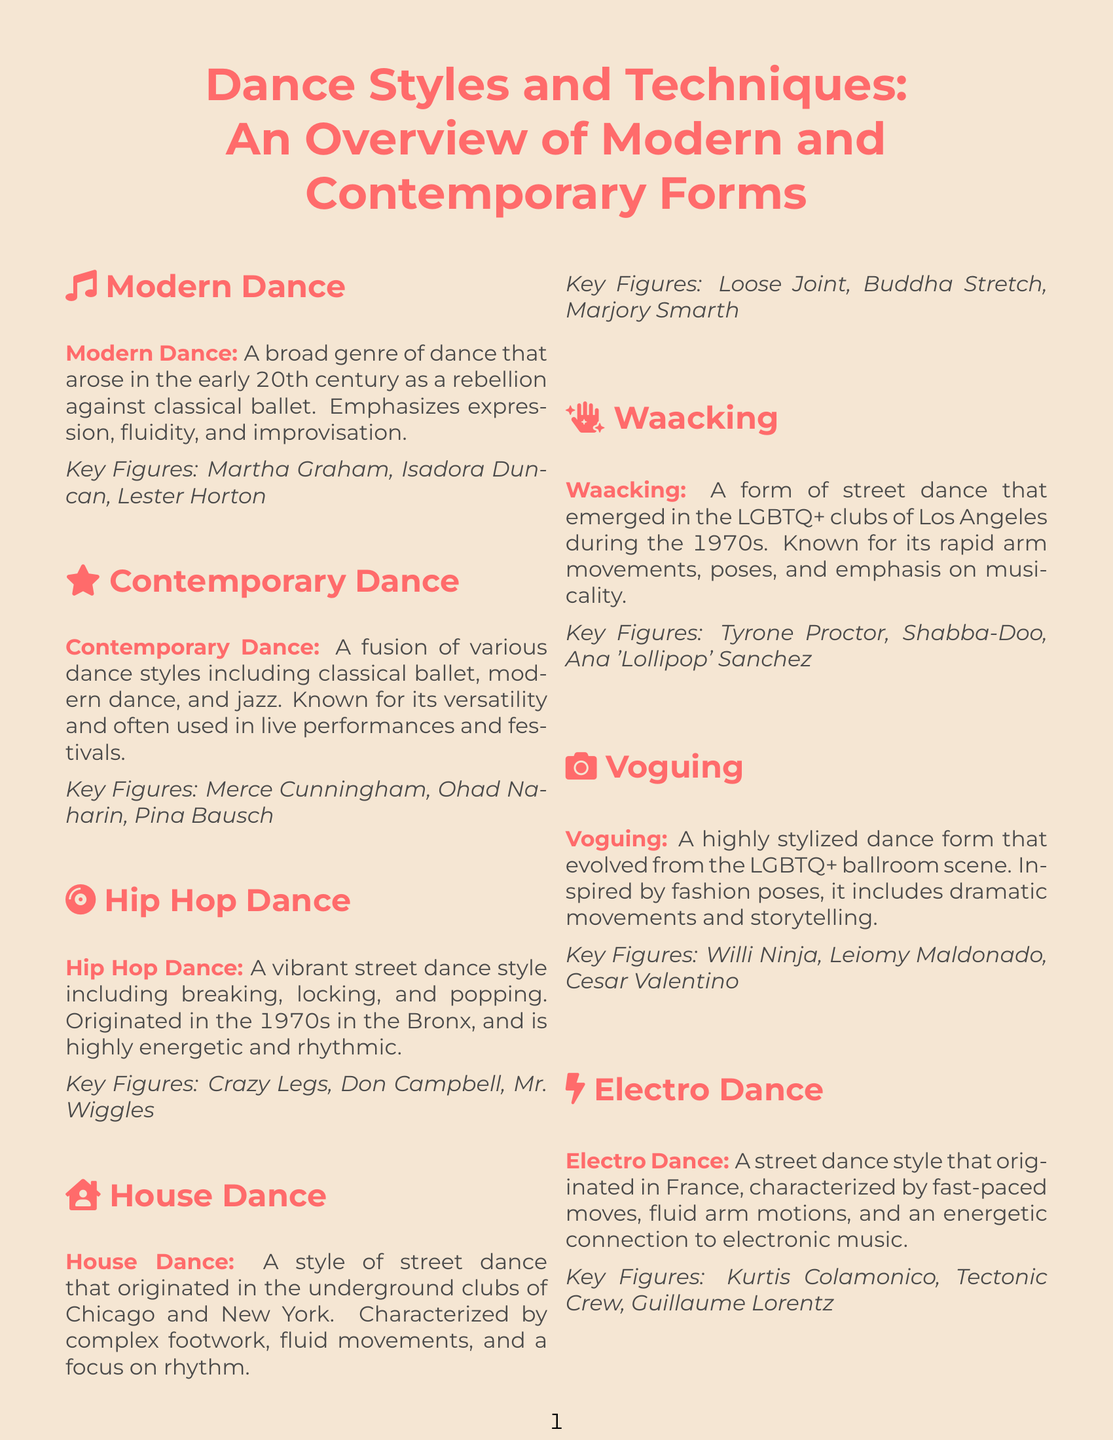What is the primary focus of Modern Dance? Modern Dance emphasizes expression, fluidity, and improvisation as a rebellion against classical ballet.
Answer: expression, fluidity, and improvisation Who are key figures in Contemporary Dance? Key figures listed for Contemporary Dance include Merce Cunningham, Ohad Naharin, and Pina Bausch.
Answer: Merce Cunningham, Ohad Naharin, Pina Bausch What is a characteristic of House Dance? House Dance is characterized by complex footwork, fluid movements, and a focus on rhythm.
Answer: complex footwork, fluid movements, and a focus on rhythm In which decade did Hip Hop Dance originate? The text states that Hip Hop Dance originated in the 1970s in the Bronx.
Answer: 1970s What type of dance is Waacking associated with? Waacking is a form of street dance that emerged in the LGBTQ+ clubs of Los Angeles.
Answer: street dance Which city is associated with the origin of Electro Dance? Electro Dance originated in France.
Answer: France How does Contact Improvisation differ from traditional dance forms? Contact Improvisation focuses on the physical connection between dancers, leveraging gravity and momentum.
Answer: physical connection What dancing style is inspired by fashion poses? Voguing is inspired by fashion poses and includes dramatic movements.
Answer: Voguing 